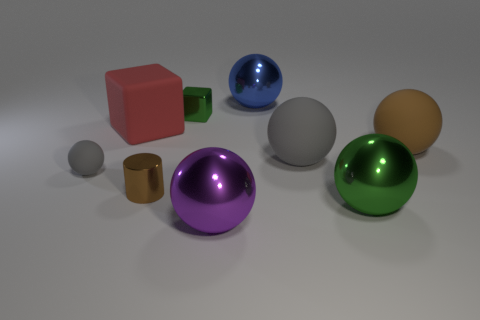Subtract all purple spheres. How many spheres are left? 5 Subtract all blue spheres. How many spheres are left? 5 Add 1 tiny green things. How many objects exist? 10 Subtract all balls. How many objects are left? 3 Subtract 2 blocks. How many blocks are left? 0 Add 8 tiny gray matte objects. How many tiny gray matte objects exist? 9 Subtract 0 cyan cylinders. How many objects are left? 9 Subtract all cyan balls. Subtract all yellow cubes. How many balls are left? 6 Subtract all yellow spheres. How many cyan blocks are left? 0 Subtract all tiny cyan matte cylinders. Subtract all large green metallic things. How many objects are left? 8 